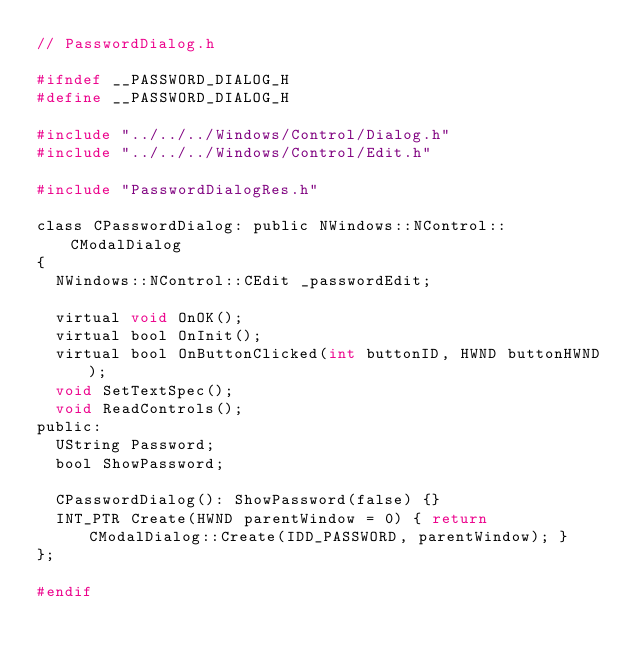<code> <loc_0><loc_0><loc_500><loc_500><_C_>// PasswordDialog.h

#ifndef __PASSWORD_DIALOG_H
#define __PASSWORD_DIALOG_H

#include "../../../Windows/Control/Dialog.h"
#include "../../../Windows/Control/Edit.h"

#include "PasswordDialogRes.h"

class CPasswordDialog: public NWindows::NControl::CModalDialog
{
  NWindows::NControl::CEdit _passwordEdit;

  virtual void OnOK();
  virtual bool OnInit();
  virtual bool OnButtonClicked(int buttonID, HWND buttonHWND);
  void SetTextSpec();
  void ReadControls();
public:
  UString Password;
  bool ShowPassword;
  
  CPasswordDialog(): ShowPassword(false) {}
  INT_PTR Create(HWND parentWindow = 0) { return CModalDialog::Create(IDD_PASSWORD, parentWindow); }
};

#endif
</code> 